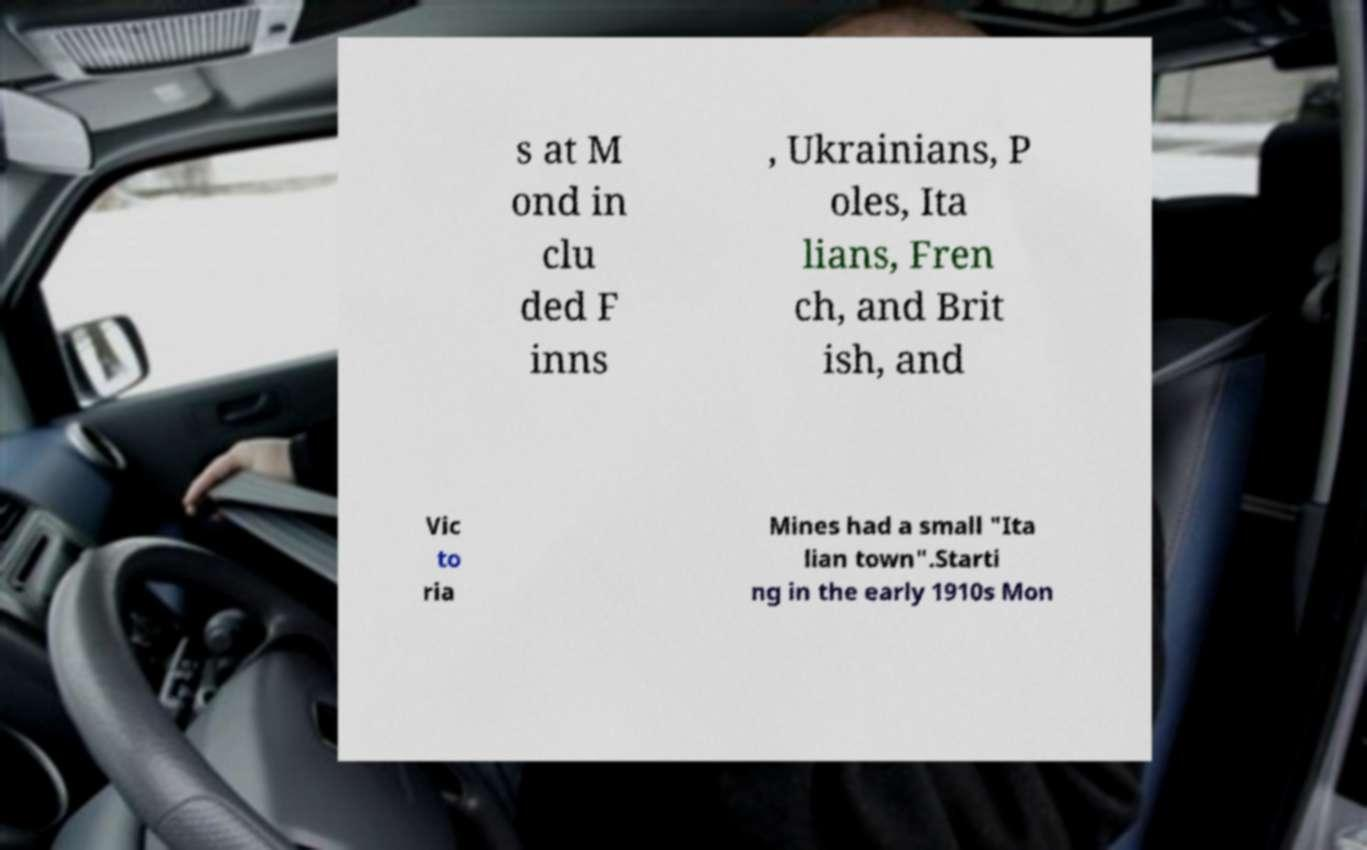Please read and relay the text visible in this image. What does it say? s at M ond in clu ded F inns , Ukrainians, P oles, Ita lians, Fren ch, and Brit ish, and Vic to ria Mines had a small "Ita lian town".Starti ng in the early 1910s Mon 